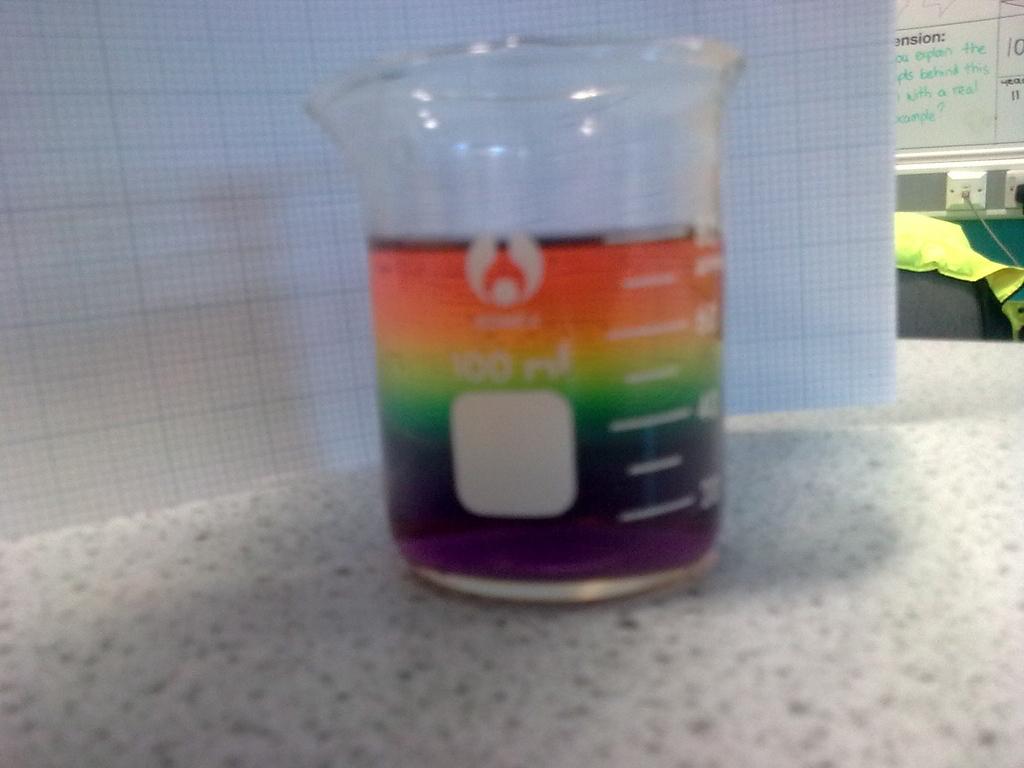How many ounces of liquid are in the beaker?
Give a very brief answer. 60. 